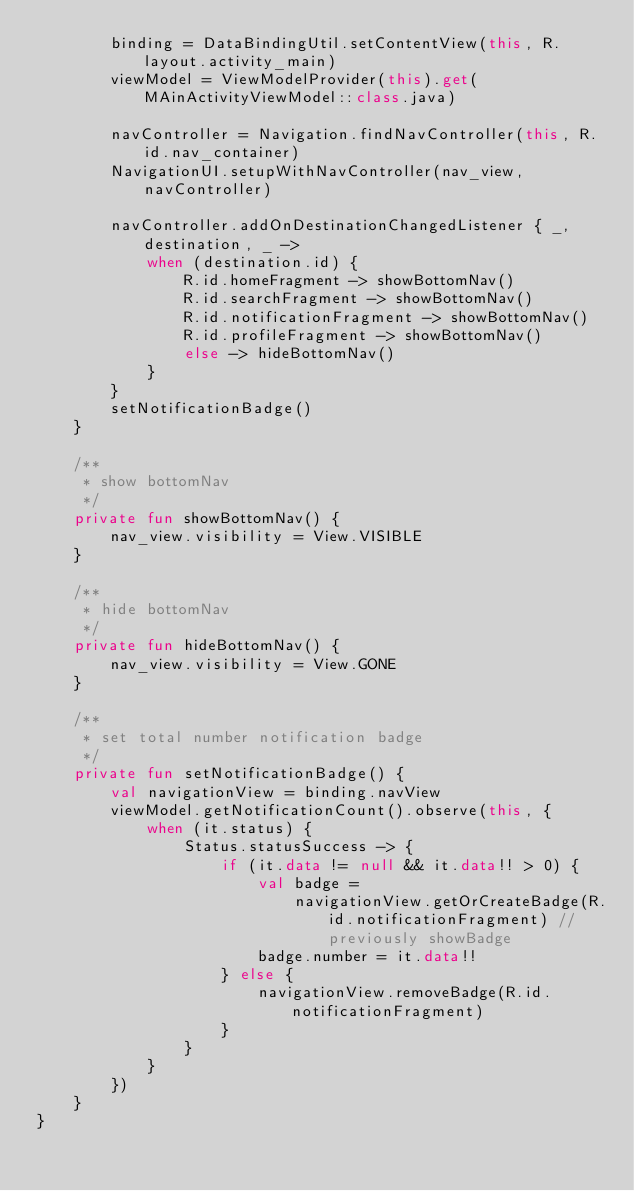Convert code to text. <code><loc_0><loc_0><loc_500><loc_500><_Kotlin_>        binding = DataBindingUtil.setContentView(this, R.layout.activity_main)
        viewModel = ViewModelProvider(this).get(MAinActivityViewModel::class.java)

        navController = Navigation.findNavController(this, R.id.nav_container)
        NavigationUI.setupWithNavController(nav_view, navController)

        navController.addOnDestinationChangedListener { _, destination, _ ->
            when (destination.id) {
                R.id.homeFragment -> showBottomNav()
                R.id.searchFragment -> showBottomNav()
                R.id.notificationFragment -> showBottomNav()
                R.id.profileFragment -> showBottomNav()
                else -> hideBottomNav()
            }
        }
        setNotificationBadge()
    }

    /**
     * show bottomNav
     */
    private fun showBottomNav() {
        nav_view.visibility = View.VISIBLE
    }

    /**
     * hide bottomNav
     */
    private fun hideBottomNav() {
        nav_view.visibility = View.GONE
    }

    /**
     * set total number notification badge
     */
    private fun setNotificationBadge() {
        val navigationView = binding.navView
        viewModel.getNotificationCount().observe(this, {
            when (it.status) {
                Status.statusSuccess -> {
                    if (it.data != null && it.data!! > 0) {
                        val badge =
                            navigationView.getOrCreateBadge(R.id.notificationFragment) // previously showBadge
                        badge.number = it.data!!
                    } else {
                        navigationView.removeBadge(R.id.notificationFragment)
                    }
                }
            }
        })
    }
}
</code> 